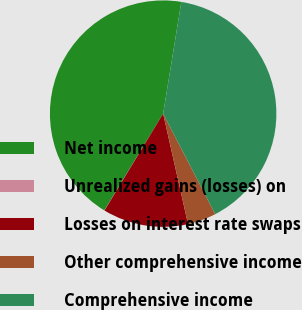Convert chart. <chart><loc_0><loc_0><loc_500><loc_500><pie_chart><fcel>Net income<fcel>Unrealized gains (losses) on<fcel>Losses on interest rate swaps<fcel>Other comprehensive income<fcel>Comprehensive income<nl><fcel>43.87%<fcel>0.03%<fcel>12.19%<fcel>4.08%<fcel>39.82%<nl></chart> 